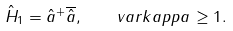<formula> <loc_0><loc_0><loc_500><loc_500>\hat { H } _ { 1 } = \hat { a } ^ { + } \overline { \hat { a } } , \quad v a r k a p p a \geq 1 .</formula> 